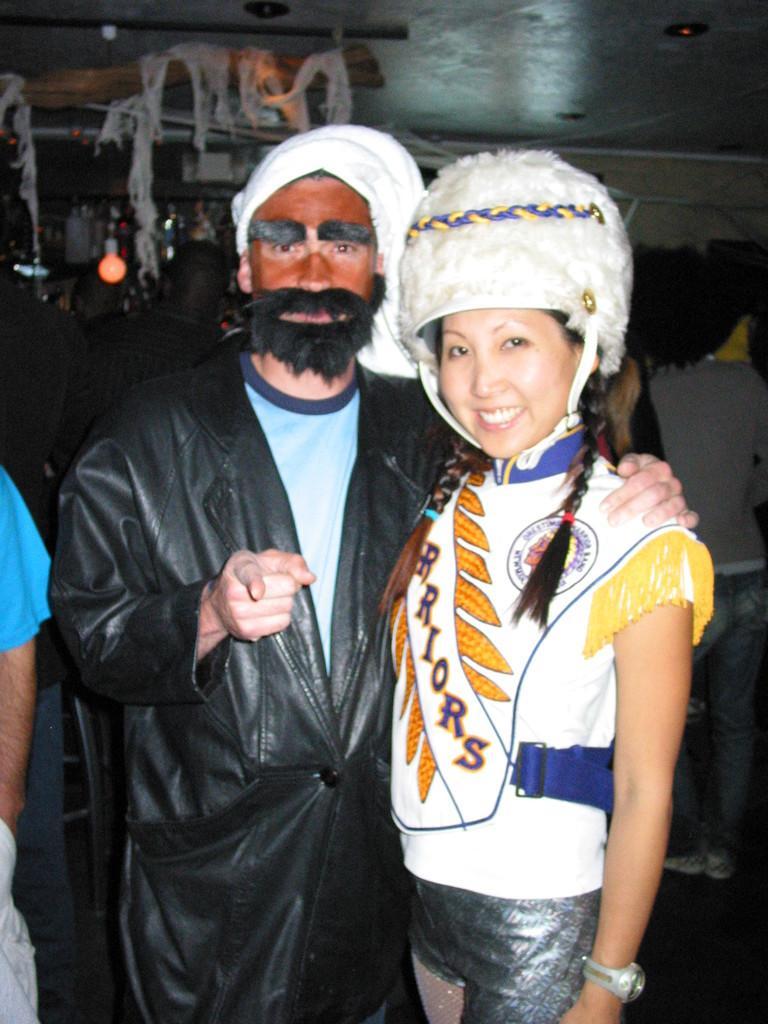Can you describe this image briefly? In this image in the front there are persons standing and smiling. On the left side there is the hand of the person. In the background there is a light and there are objects hanging which are white in colour. 